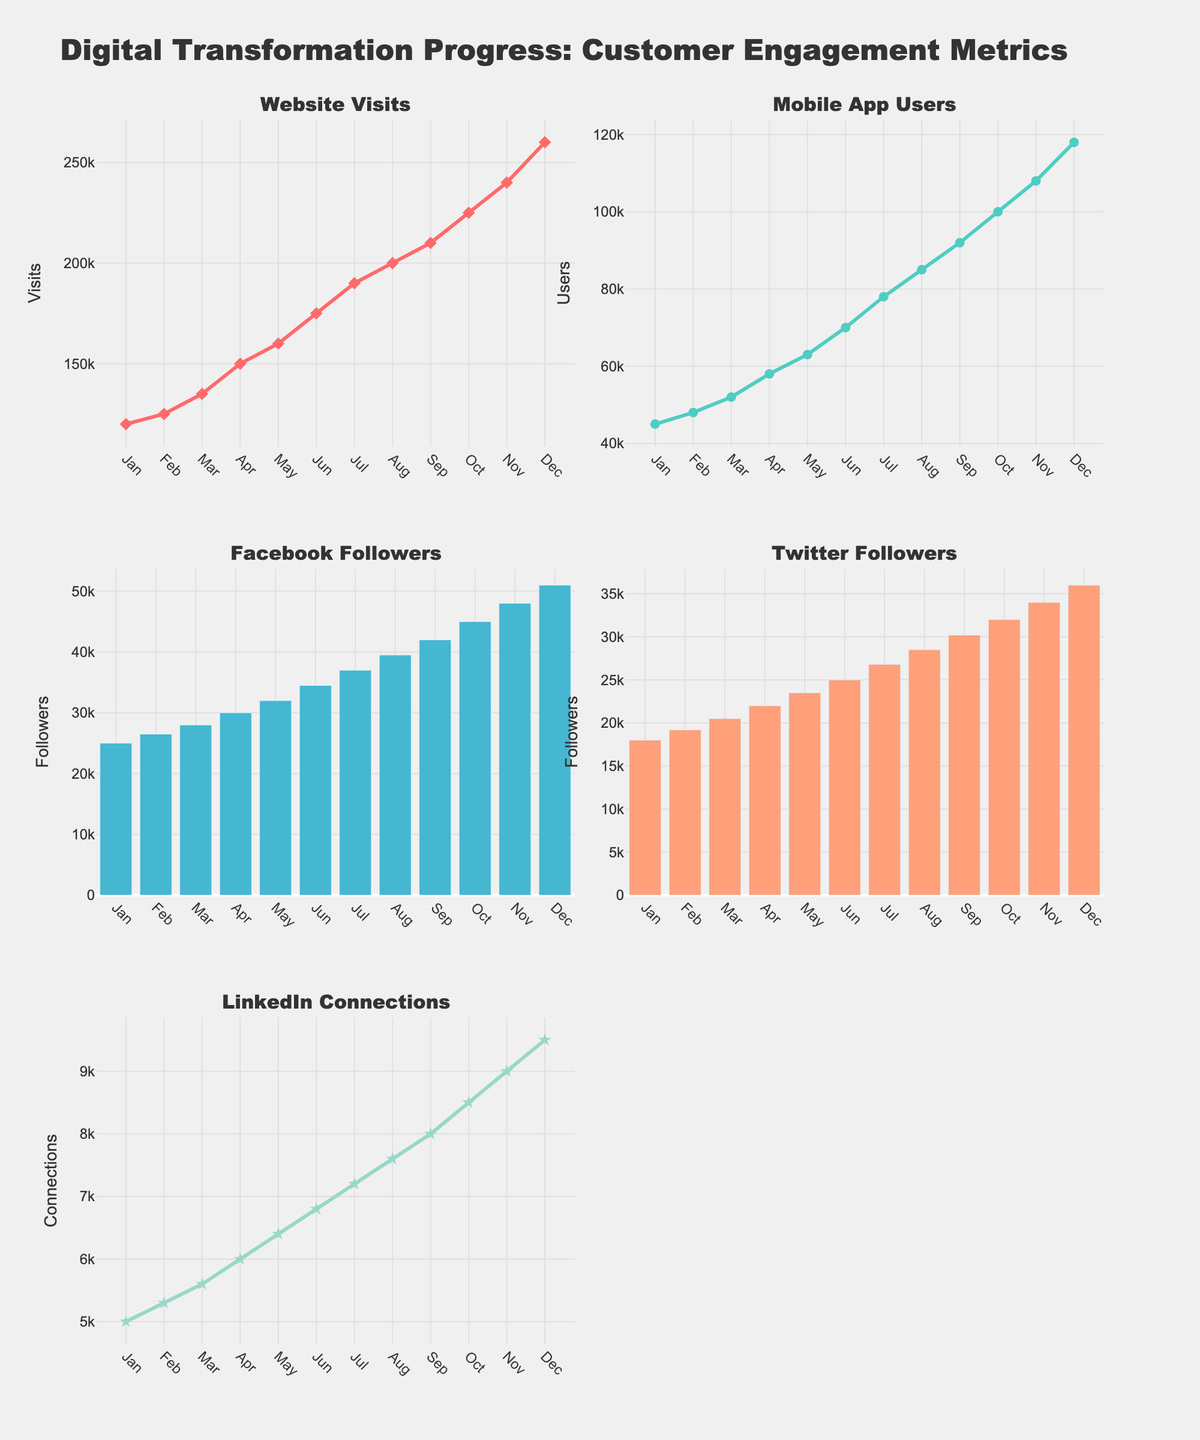What is the title of the figure? The title is displayed at the top of the figure and is meant to describe the overall content of the plots. The title reads, "Digital Transformation Progress: Customer Engagement Metrics".
Answer: Digital Transformation Progress: Customer Engagement Metrics What is the trend in website visits over the past year? The subplot for Website Visits shows a line chart. Observing the trend, there is a steady increase in the number of visits from 120,000 in January to 260,000 in December.
Answer: Steady increase How many mobile app users were there in June? By looking at the "Mobile App Users" subplot in June, the data point can be observed at the 70,000 mark.
Answer: 70,000 In which month did LinkedIn Connections reach 9,500? By referring to the subplot for LinkedIn Connections, December is the month where the data point touches 9,500.
Answer: December Compare the number of Facebook Followers and Twitter Followers in September. Which is higher? Observing the subplots for Facebook Followers (bar chart) and Twitter Followers (bar chart) in September, Facebook has 42,000 followers while Twitter has 30,200 followers. Therefore, Facebook has more followers.
Answer: Facebook Calculate the average number of Website Visits over the entire year. The total number of Website Visits is the sum of the monthly visits: 120,000 + 125,000 + 135,000 + 150,000 + 160,000 + 175,000 + 190,000 + 200,000 + 210,000 + 225,000 + 240,000 + 260,000 = 2,190,000. Dividing by 12 months, the average is 2,190,000 / 12 = 182,500.
Answer: 182,500 Which channel had the highest growth in user engagement over the past year? Analyzing the growth of each channel: Website Visits increased from 120,000 to 260,000, Mobile App Users from 45,000 to 118,000, Facebook Followers from 25,000 to 51,000, Twitter Followers from 18,000 to 36,000, and LinkedIn Connections from 5,000 to 9,500. The highest absolute growth is in Website Visits with an increase of 140,000.
Answer: Website Visits What is the combined total of Twitter Followers in March and April? Referring to the subplot for Twitter Followers, March has 20,500 followers and April has 22,000 followers. Combined, it is 20,500 + 22,000 = 42,500.
Answer: 42,500 Describe the visual style of the Facebook Followers subplot. The Facebook Followers subplot is represented using a bar chart with bars in a distinctive light blue color.
Answer: Bar chart with light blue bars What pattern can be observed in Mobile App Users from July to November? In the subplot for Mobile App Users, from July (78,000) to November (108,000), the trend shows a consistent monthly increase in the number of users.
Answer: Consistent increase 